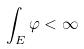<formula> <loc_0><loc_0><loc_500><loc_500>\int _ { E } \varphi < \infty</formula> 